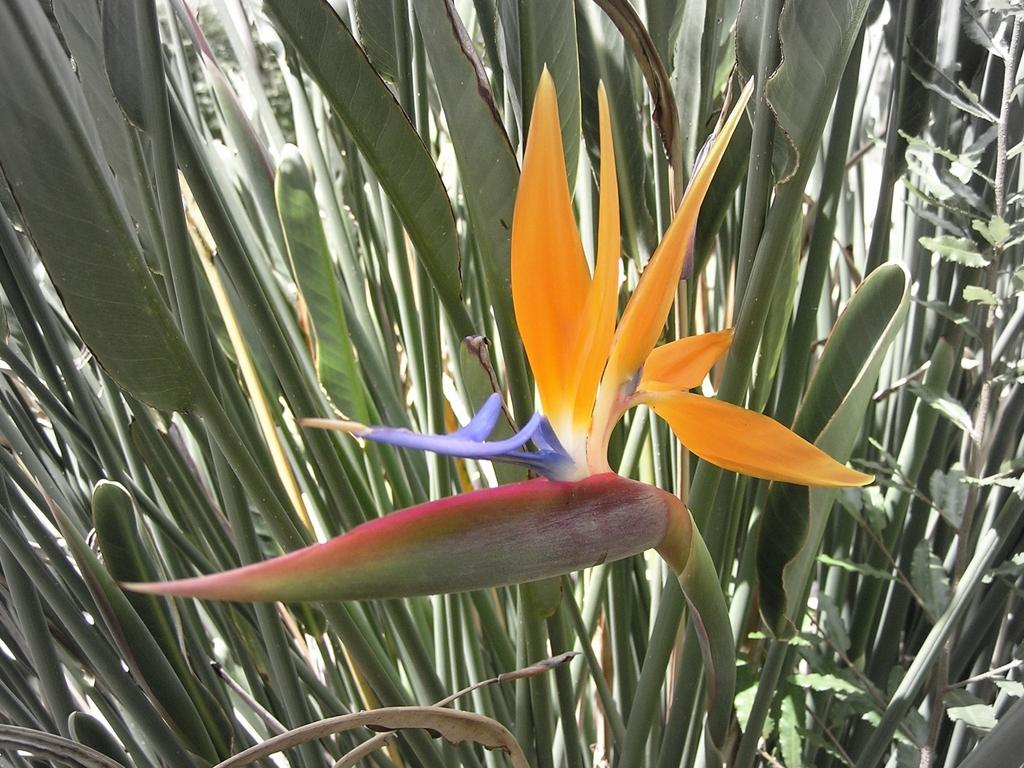What is located on the right side of the image? There is a plant on the right side of the image. What specific feature can be seen on the plant? The plant has a flower. What color are the leaves of the plant? The plant has green leaves. What can be seen in the background of the image? There are plants visible in the background of the image. How many mint leaves are visible in the image? There is no mention of mint leaves in the image; it features a plant with a flower and green leaves. What type of account is being discussed in the image? There is no account or financial information present in the image; it is focused on a plant with a flower and green leaves. 